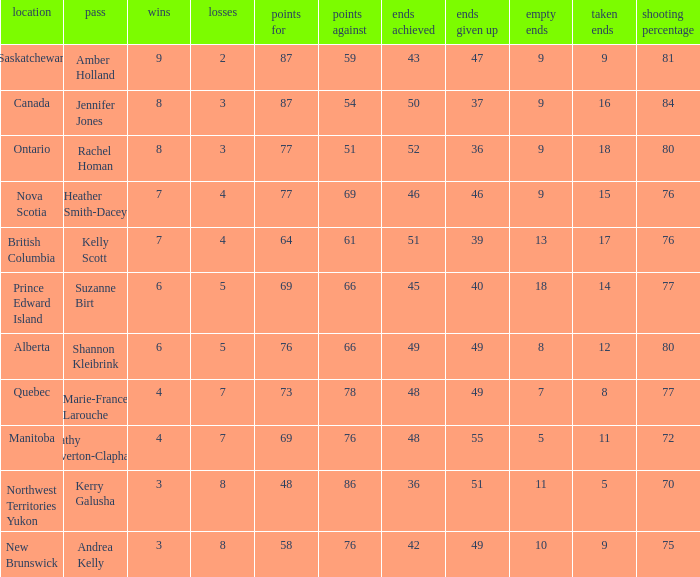If the locale is Ontario, what is the W minimum? 8.0. 